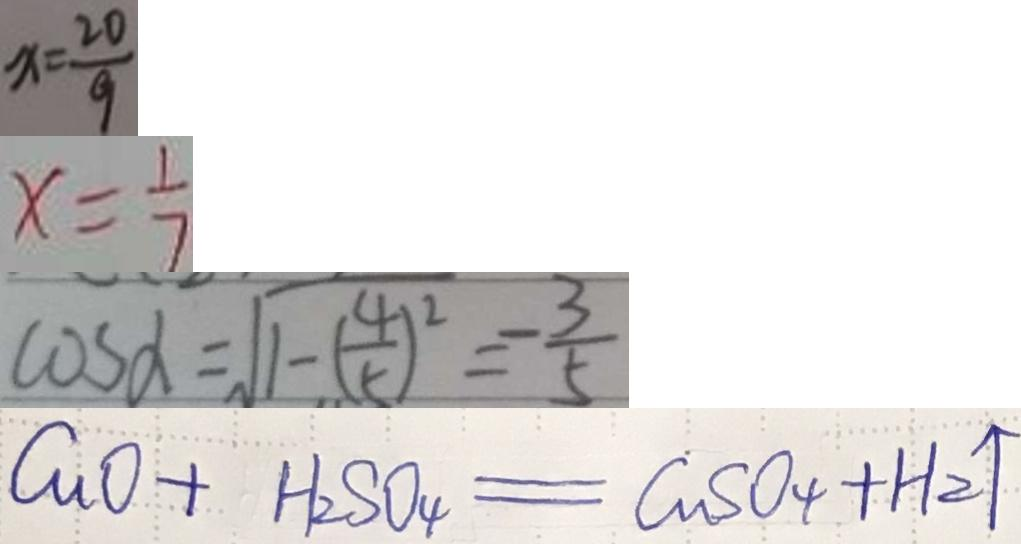<formula> <loc_0><loc_0><loc_500><loc_500>x = \frac { 2 0 } { 9 } 
 x = \frac { 1 } { 7 } 
 \cos \alpha = \sqrt { 1 - ( \frac { 4 } { 5 } ) ^ { 2 } } = - \frac { 3 } { 5 } 
 C u O + H _ { 2 } S O _ { 4 } = C a S O _ { 4 } + H _ { 2 } \uparrow</formula> 